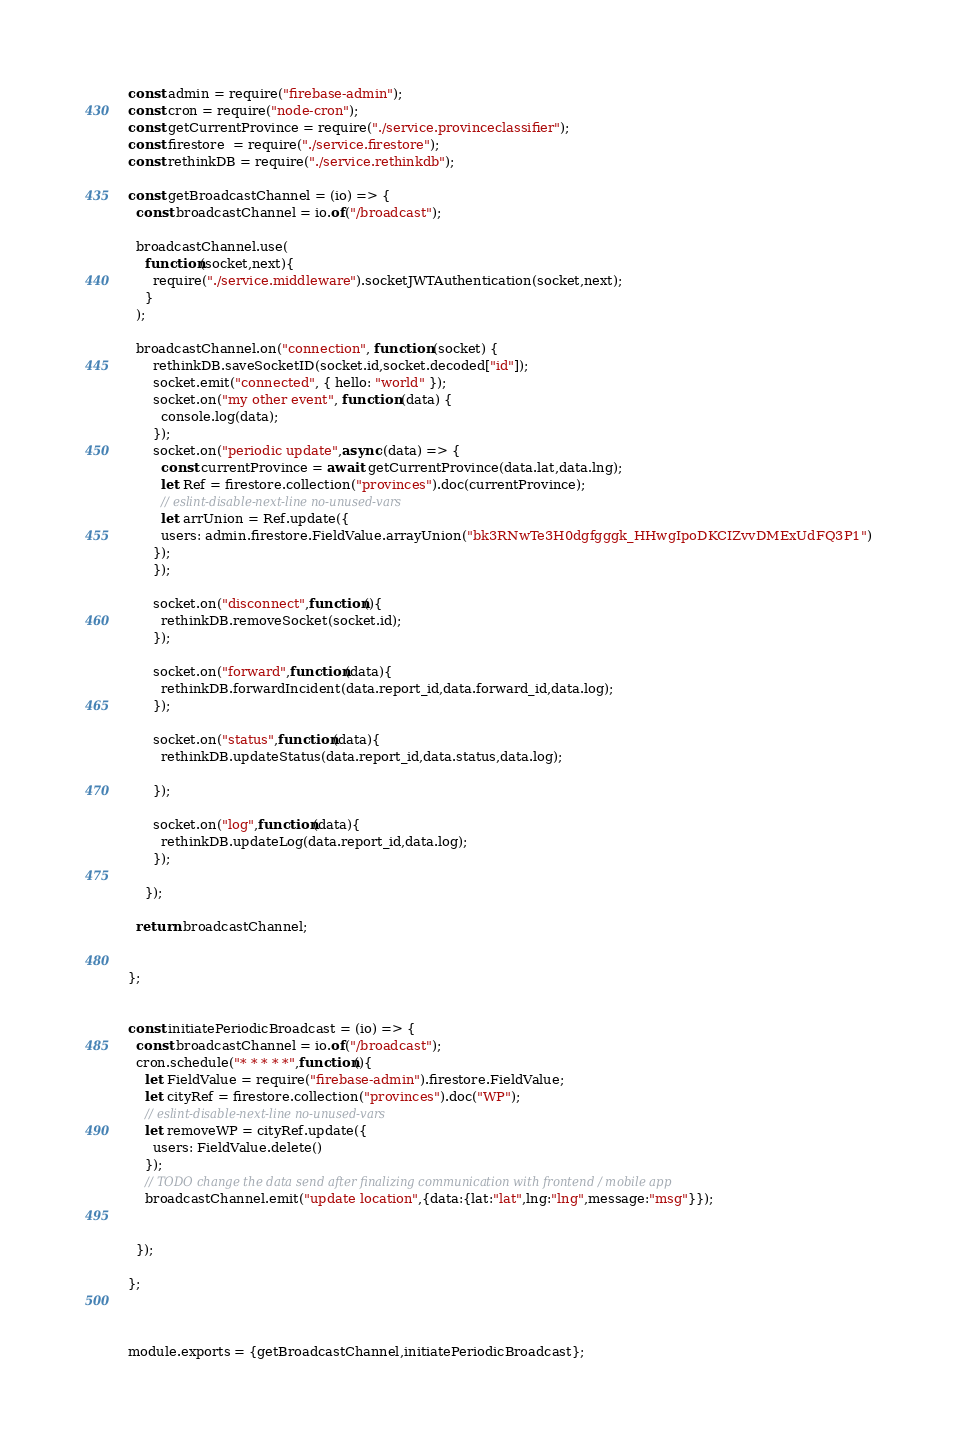Convert code to text. <code><loc_0><loc_0><loc_500><loc_500><_JavaScript_>const admin = require("firebase-admin");
const cron = require("node-cron");
const getCurrentProvince = require("./service.provinceclassifier");
const firestore  = require("./service.firestore");
const rethinkDB = require("./service.rethinkdb");

const getBroadcastChannel = (io) => {
  const broadcastChannel = io.of("/broadcast");
  
  broadcastChannel.use(
    function(socket,next){
      require("./service.middleware").socketJWTAuthentication(socket,next);
    }
  );

  broadcastChannel.on("connection", function (socket) {
      rethinkDB.saveSocketID(socket.id,socket.decoded["id"]);
      socket.emit("connected", { hello: "world" });
      socket.on("my other event", function (data) {
        console.log(data);
      });
      socket.on("periodic update",async (data) => {
        const currentProvince = await getCurrentProvince(data.lat,data.lng);
        let Ref = firestore.collection("provinces").doc(currentProvince);
        // eslint-disable-next-line no-unused-vars
        let arrUnion = Ref.update({
        users: admin.firestore.FieldValue.arrayUnion("bk3RNwTe3H0dgfgggk_HHwgIpoDKCIZvvDMExUdFQ3P1")
      });
      });

      socket.on("disconnect",function(){
        rethinkDB.removeSocket(socket.id);
      });

      socket.on("forward",function(data){
        rethinkDB.forwardIncident(data.report_id,data.forward_id,data.log);
      });

      socket.on("status",function(data){
        rethinkDB.updateStatus(data.report_id,data.status,data.log);

      });

      socket.on("log",function(data){
        rethinkDB.updateLog(data.report_id,data.log);
      });
      
    });
  
  return broadcastChannel;


};


const initiatePeriodicBroadcast = (io) => {
  const broadcastChannel = io.of("/broadcast");
  cron.schedule("* * * * *",function(){
    let FieldValue = require("firebase-admin").firestore.FieldValue;
    let cityRef = firestore.collection("provinces").doc("WP");
    // eslint-disable-next-line no-unused-vars
    let removeWP = cityRef.update({
      users: FieldValue.delete()
    });
    // TODO change the data send after finalizing communication with frontend / mobile app
    broadcastChannel.emit("update location",{data:{lat:"lat",lng:"lng",message:"msg"}});
    
    
  });

};



module.exports = {getBroadcastChannel,initiatePeriodicBroadcast};
</code> 